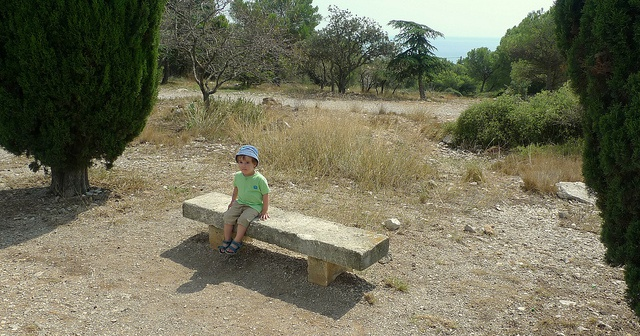Describe the objects in this image and their specific colors. I can see bench in black, gray, and beige tones and people in black, gray, and green tones in this image. 